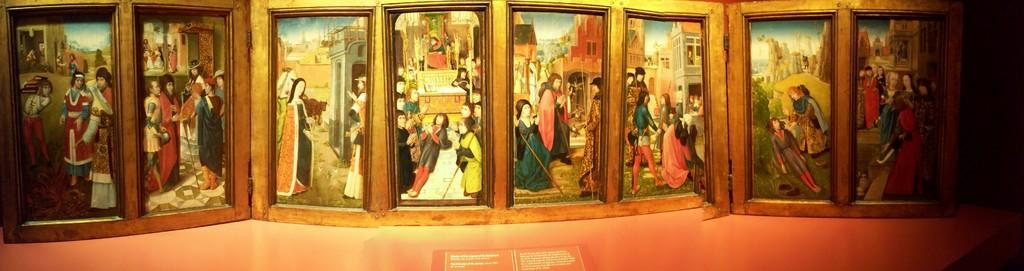What type of artwork is present in the image? There are portraits in the image. What type of screw is visible in the image? There is no screw present in the image; it only contains portraits. Can you describe the throne in the image? There is no throne present in the image; it only contains portraits. 